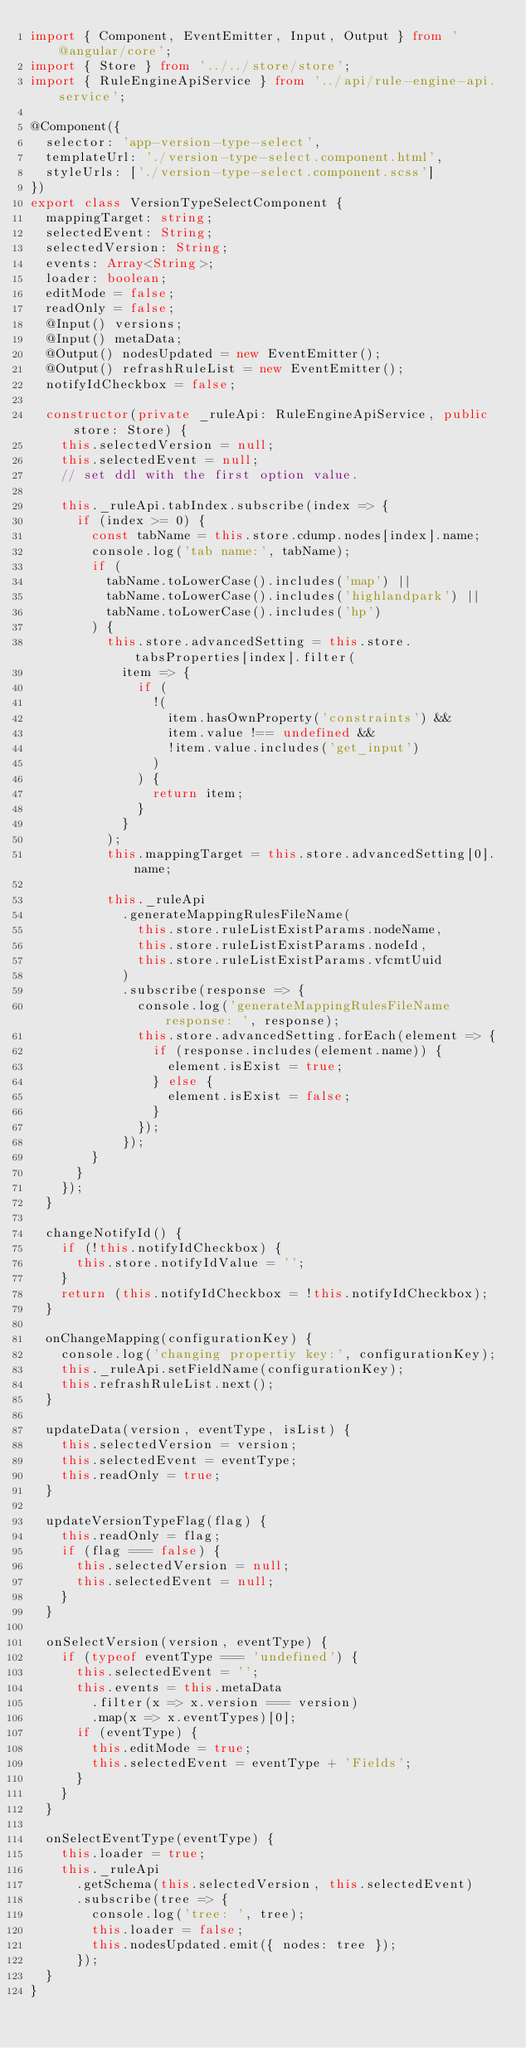<code> <loc_0><loc_0><loc_500><loc_500><_TypeScript_>import { Component, EventEmitter, Input, Output } from '@angular/core';
import { Store } from '../../store/store';
import { RuleEngineApiService } from '../api/rule-engine-api.service';

@Component({
  selector: 'app-version-type-select',
  templateUrl: './version-type-select.component.html',
  styleUrls: ['./version-type-select.component.scss']
})
export class VersionTypeSelectComponent {
  mappingTarget: string;
  selectedEvent: String;
  selectedVersion: String;
  events: Array<String>;
  loader: boolean;
  editMode = false;
  readOnly = false;
  @Input() versions;
  @Input() metaData;
  @Output() nodesUpdated = new EventEmitter();
  @Output() refrashRuleList = new EventEmitter();
  notifyIdCheckbox = false;

  constructor(private _ruleApi: RuleEngineApiService, public store: Store) {
    this.selectedVersion = null;
    this.selectedEvent = null;
    // set ddl with the first option value.

    this._ruleApi.tabIndex.subscribe(index => {
      if (index >= 0) {
        const tabName = this.store.cdump.nodes[index].name;
        console.log('tab name:', tabName);
        if (
          tabName.toLowerCase().includes('map') ||
          tabName.toLowerCase().includes('highlandpark') ||
          tabName.toLowerCase().includes('hp')
        ) {
          this.store.advancedSetting = this.store.tabsProperties[index].filter(
            item => {
              if (
                !(
                  item.hasOwnProperty('constraints') &&
                  item.value !== undefined &&
                  !item.value.includes('get_input')
                )
              ) {
                return item;
              }
            }
          );
          this.mappingTarget = this.store.advancedSetting[0].name;

          this._ruleApi
            .generateMappingRulesFileName(
              this.store.ruleListExistParams.nodeName,
              this.store.ruleListExistParams.nodeId,
              this.store.ruleListExistParams.vfcmtUuid
            )
            .subscribe(response => {
              console.log('generateMappingRulesFileName response: ', response);
              this.store.advancedSetting.forEach(element => {
                if (response.includes(element.name)) {
                  element.isExist = true;
                } else {
                  element.isExist = false;
                }
              });
            });
        }
      }
    });
  }

  changeNotifyId() {
    if (!this.notifyIdCheckbox) {
      this.store.notifyIdValue = '';
    }
    return (this.notifyIdCheckbox = !this.notifyIdCheckbox);
  }

  onChangeMapping(configurationKey) {
    console.log('changing propertiy key:', configurationKey);
    this._ruleApi.setFieldName(configurationKey);
    this.refrashRuleList.next();
  }

  updateData(version, eventType, isList) {
    this.selectedVersion = version;
    this.selectedEvent = eventType;
    this.readOnly = true;
  }

  updateVersionTypeFlag(flag) {
    this.readOnly = flag;
    if (flag === false) {
      this.selectedVersion = null;
      this.selectedEvent = null;
    }
  }

  onSelectVersion(version, eventType) {
    if (typeof eventType === 'undefined') {
      this.selectedEvent = '';
      this.events = this.metaData
        .filter(x => x.version === version)
        .map(x => x.eventTypes)[0];
      if (eventType) {
        this.editMode = true;
        this.selectedEvent = eventType + 'Fields';
      }
    }
  }

  onSelectEventType(eventType) {
    this.loader = true;
    this._ruleApi
      .getSchema(this.selectedVersion, this.selectedEvent)
      .subscribe(tree => {
        console.log('tree: ', tree);
        this.loader = false;
        this.nodesUpdated.emit({ nodes: tree });
      });
  }
}
</code> 